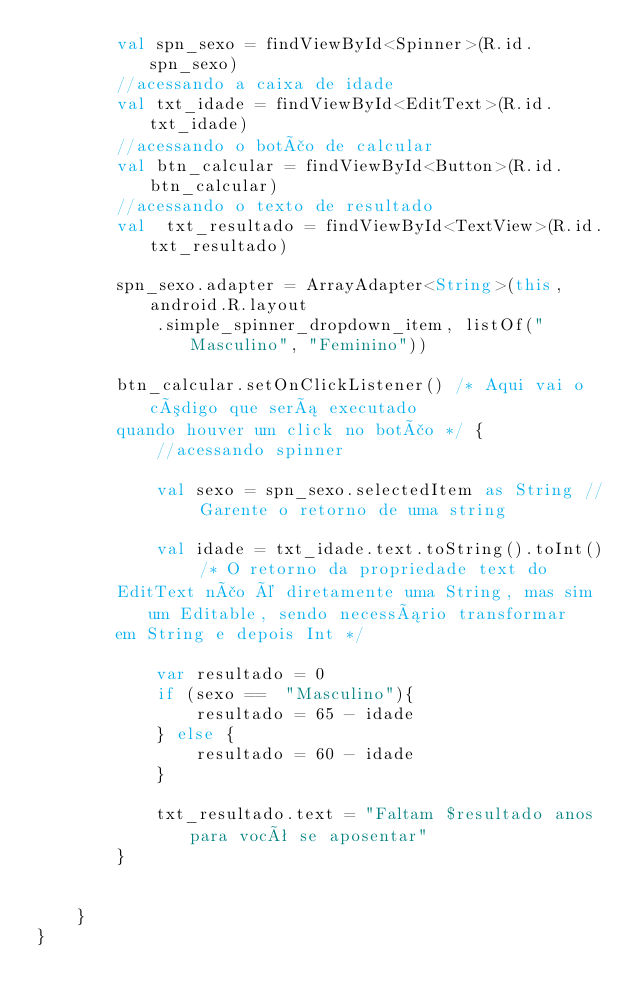<code> <loc_0><loc_0><loc_500><loc_500><_Kotlin_>        val spn_sexo = findViewById<Spinner>(R.id.spn_sexo)
        //acessando a caixa de idade
        val txt_idade = findViewById<EditText>(R.id.txt_idade)
        //acessando o botão de calcular
        val btn_calcular = findViewById<Button>(R.id.btn_calcular)
        //acessando o texto de resultado
        val  txt_resultado = findViewById<TextView>(R.id.txt_resultado)

        spn_sexo.adapter = ArrayAdapter<String>(this, android.R.layout
            .simple_spinner_dropdown_item, listOf("Masculino", "Feminino"))

        btn_calcular.setOnClickListener() /* Aqui vai o código que será executado
        quando houver um click no botão */ {
            //acessando spinner

            val sexo = spn_sexo.selectedItem as String // Garente o retorno de uma string

            val idade = txt_idade.text.toString().toInt() /* O retorno da propriedade text do
        EditText não é diretamente uma String, mas sim um Editable, sendo necessário transformar
        em String e depois Int */

            var resultado = 0
            if (sexo ==  "Masculino"){
                resultado = 65 - idade
            } else {
                resultado = 60 - idade
            }

            txt_resultado.text = "Faltam $resultado anos para você se aposentar"
        }


    }
}</code> 